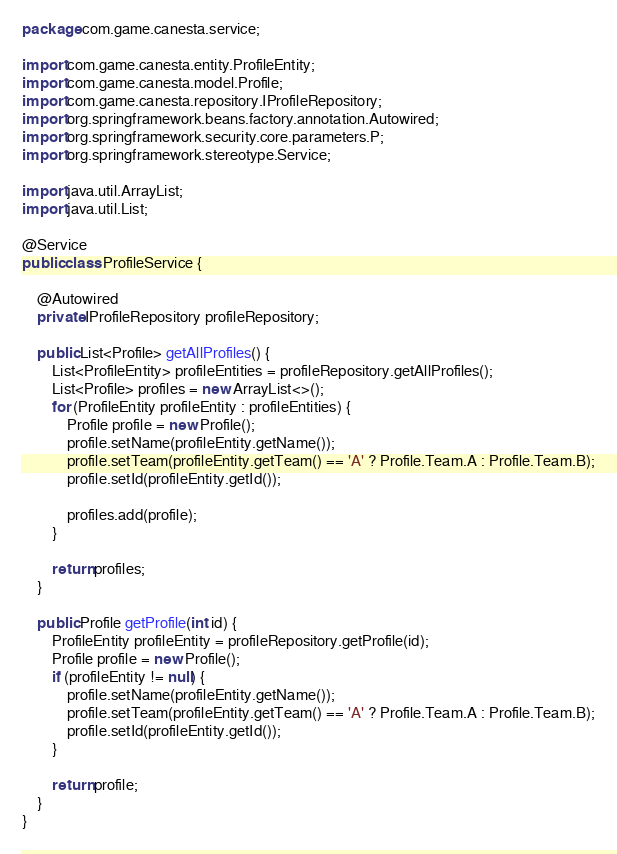<code> <loc_0><loc_0><loc_500><loc_500><_Java_>package com.game.canesta.service;

import com.game.canesta.entity.ProfileEntity;
import com.game.canesta.model.Profile;
import com.game.canesta.repository.IProfileRepository;
import org.springframework.beans.factory.annotation.Autowired;
import org.springframework.security.core.parameters.P;
import org.springframework.stereotype.Service;

import java.util.ArrayList;
import java.util.List;

@Service
public class ProfileService {

    @Autowired
    private IProfileRepository profileRepository;

    public List<Profile> getAllProfiles() {
        List<ProfileEntity> profileEntities = profileRepository.getAllProfiles();
        List<Profile> profiles = new ArrayList<>();
        for (ProfileEntity profileEntity : profileEntities) {
            Profile profile = new Profile();
            profile.setName(profileEntity.getName());
            profile.setTeam(profileEntity.getTeam() == 'A' ? Profile.Team.A : Profile.Team.B);
            profile.setId(profileEntity.getId());

            profiles.add(profile);
        }

        return profiles;
    }

    public Profile getProfile(int id) {
        ProfileEntity profileEntity = profileRepository.getProfile(id);
        Profile profile = new Profile();
        if (profileEntity != null) {
            profile.setName(profileEntity.getName());
            profile.setTeam(profileEntity.getTeam() == 'A' ? Profile.Team.A : Profile.Team.B);
            profile.setId(profileEntity.getId());
        }

        return profile;
    }
}
</code> 